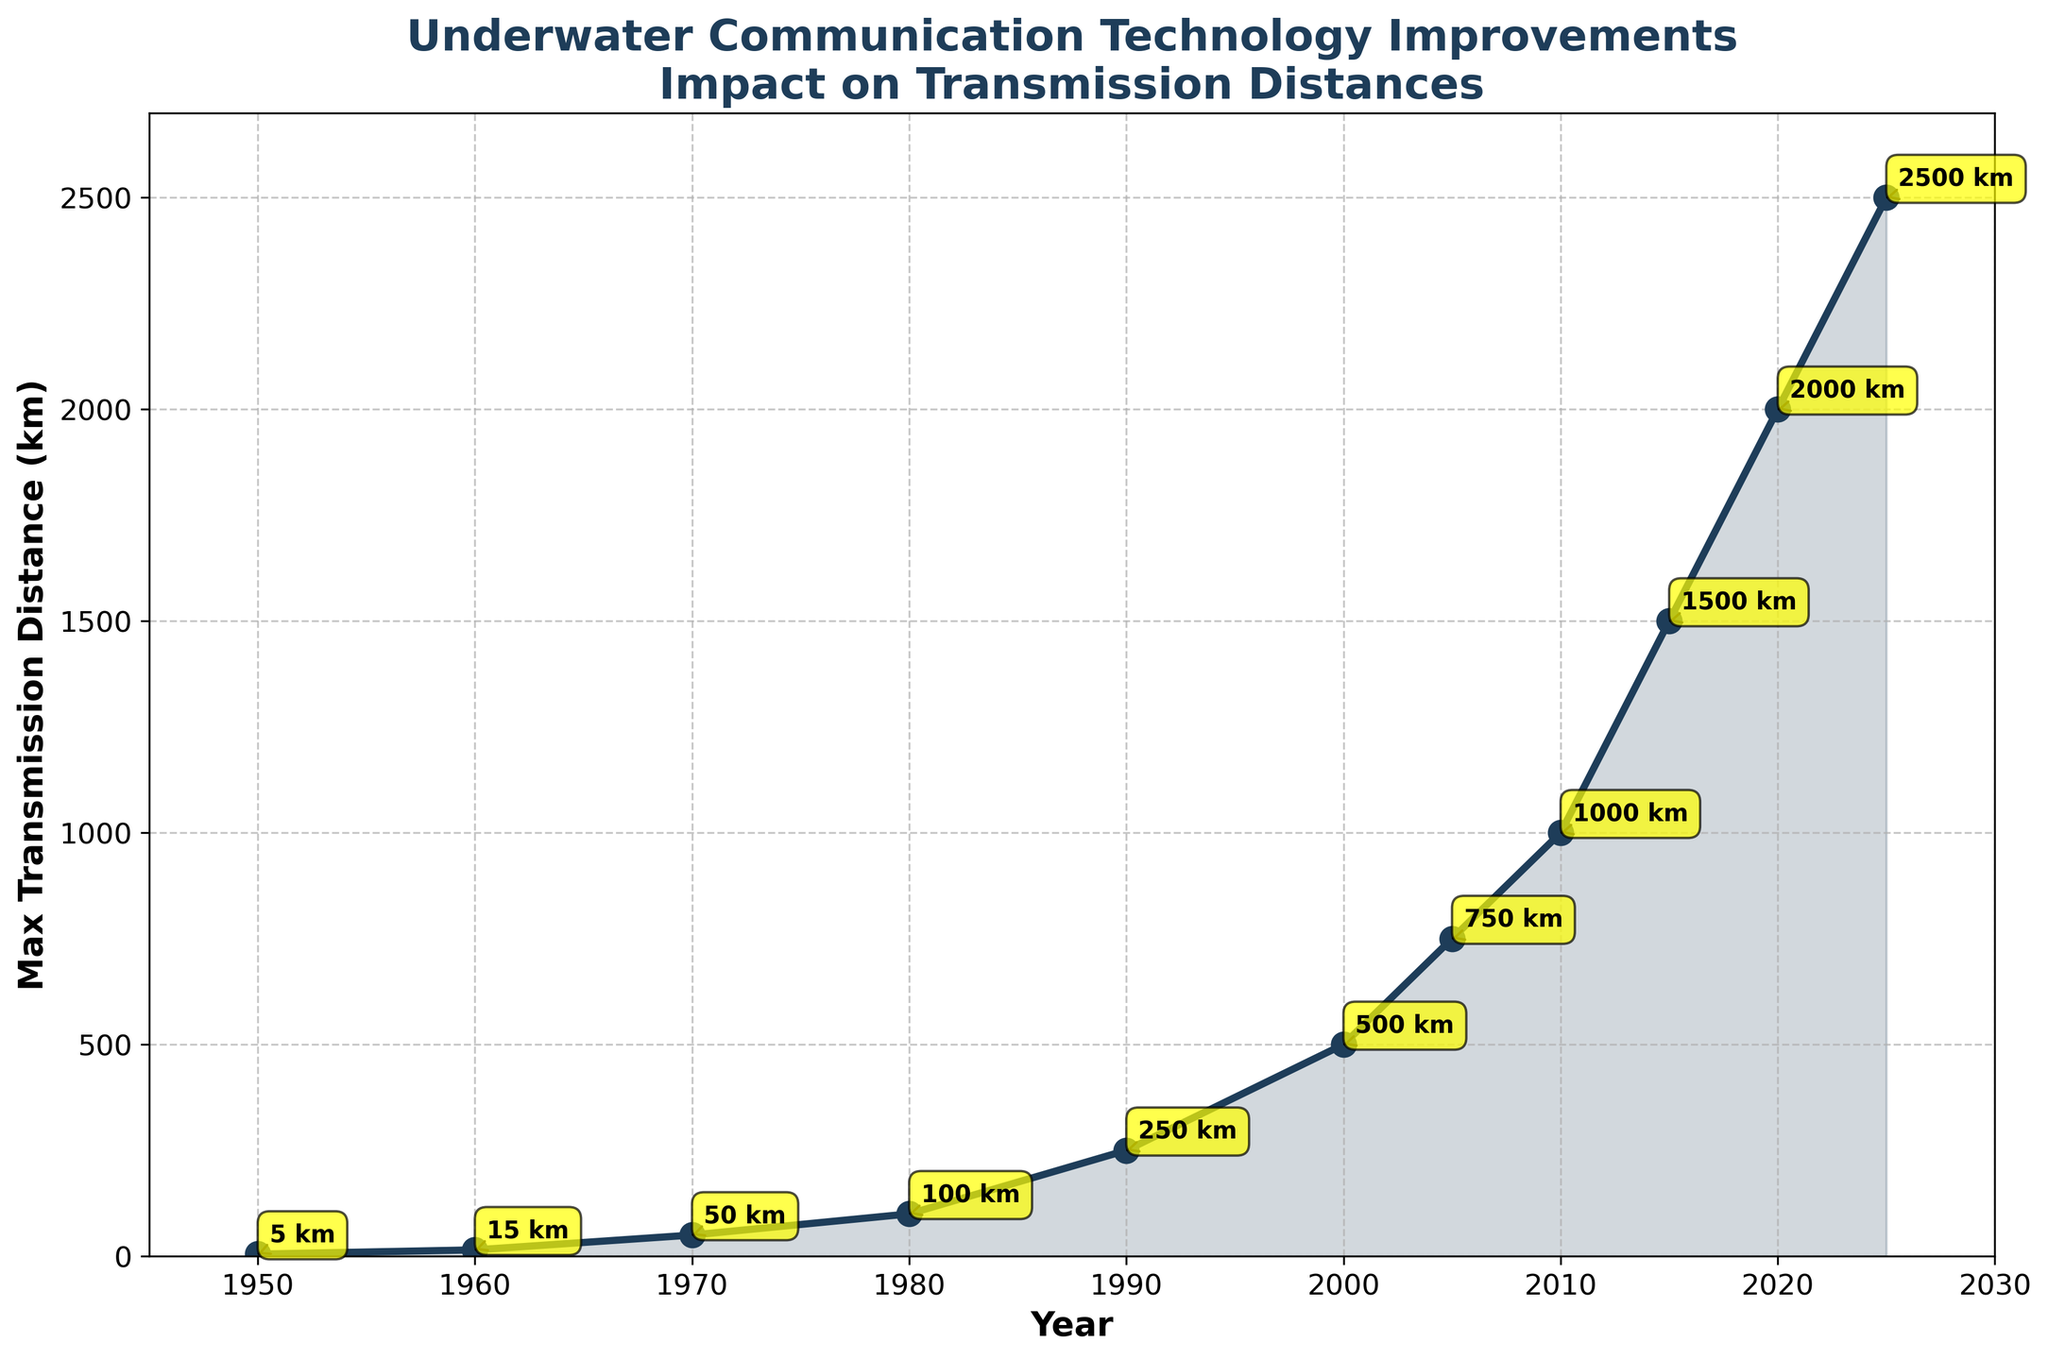What year first saw a maximum transmission distance of more than 1000 km? Identify the point where the transmission distance crosses 1000 km and check the corresponding year. From the data, this occurs between 2010 and 2015. Verifying visually from the graph, 2015 is the first year with a transmission distance above 1000 km.
Answer: 2015 What is the total increase in maximum transmission distance from 1950 to 2025? Find the difference between the transmission distances in 1950 and 2025 (2500 km - 5 km).
Answer: 2495 km By how much did the maximum transmission distance increase between 2000 and 2010? Find the difference between the transmission distances in 2000 and 2010 (1000 km - 500 km).
Answer: 500 km Compare the transmission distances between 1990 and 2010. Which year had a higher distance and by how much? Find the transmission distances for 1990 (250 km) and 2010 (1000 km) and calculate the difference (1000 km - 250 km).
Answer: 2010, by 750 km What visual element is used to annotate the exact transmission distances on the plot? Look for textual or graphical elements indicating distances. The plot uses text annotations with numeric values at each data point.
Answer: Text annotations What is the trend in maximum transmission distances from 1950 to 2025? Identify the overall direction of the transmission distances from the start to end years by examining the plot. The transmission distance consistently increases over time.
Answer: Increasing Which year is annotated with the value '5 km'? Locate the '5 km' annotation on the plot and find the corresponding year. The annotation for '5 km' is at the year 1950.
Answer: 1950 